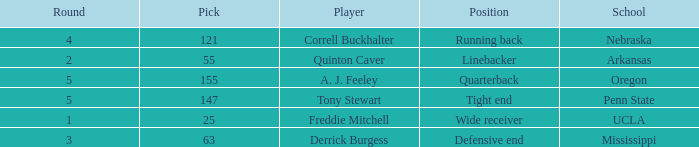What position did the player who was picked in round 3 play? Defensive end. 